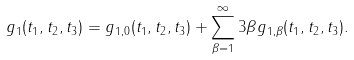<formula> <loc_0><loc_0><loc_500><loc_500>g _ { 1 } ( t _ { 1 } , t _ { 2 } , t _ { 3 } ) = g _ { 1 , 0 } ( t _ { 1 } , t _ { 2 } , t _ { 3 } ) + \sum _ { \beta = 1 } ^ { \infty } 3 \beta g _ { 1 , \beta } ( t _ { 1 } , t _ { 2 } , t _ { 3 } ) .</formula> 